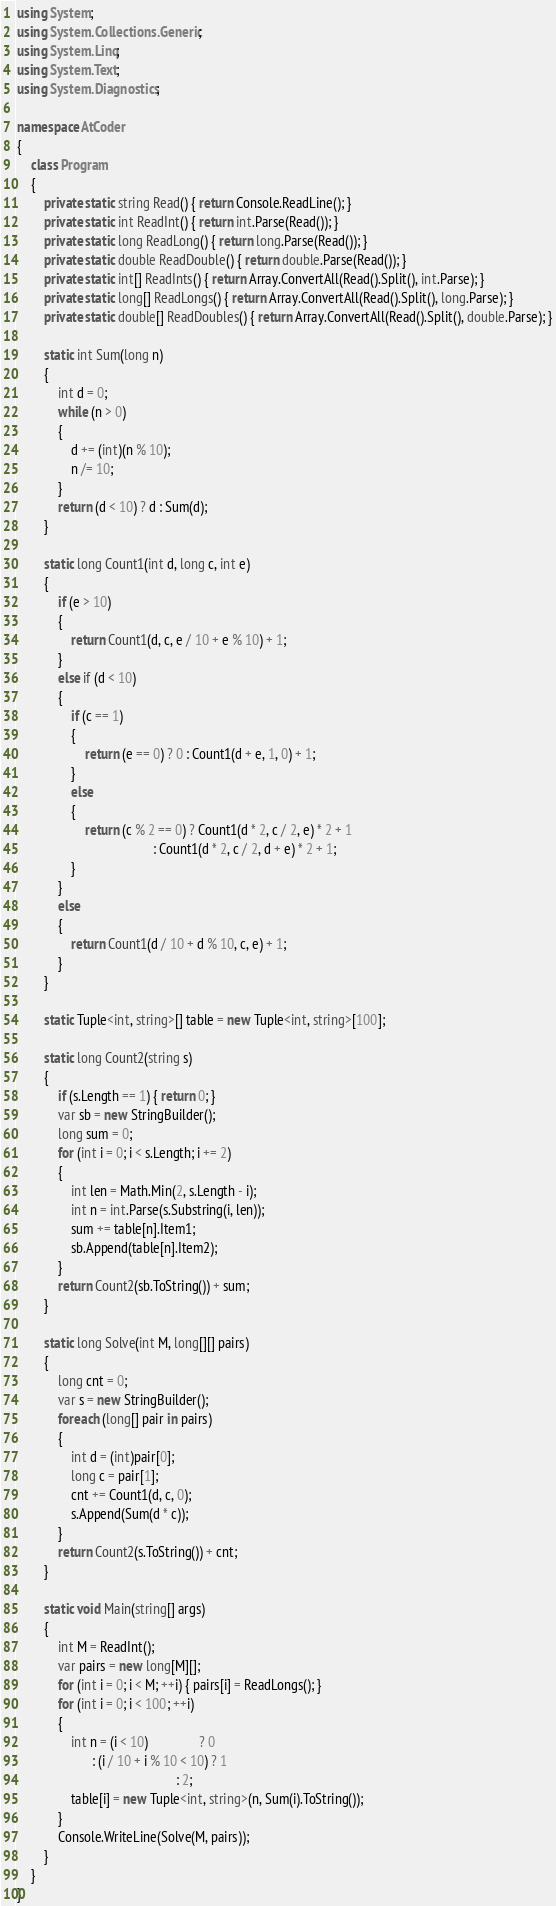Convert code to text. <code><loc_0><loc_0><loc_500><loc_500><_C#_>using System;
using System.Collections.Generic;
using System.Linq;
using System.Text;
using System.Diagnostics;

namespace AtCoder
{
    class Program
    {
        private static string Read() { return Console.ReadLine(); }
        private static int ReadInt() { return int.Parse(Read()); }
        private static long ReadLong() { return long.Parse(Read()); }
        private static double ReadDouble() { return double.Parse(Read()); }
        private static int[] ReadInts() { return Array.ConvertAll(Read().Split(), int.Parse); }
        private static long[] ReadLongs() { return Array.ConvertAll(Read().Split(), long.Parse); }
        private static double[] ReadDoubles() { return Array.ConvertAll(Read().Split(), double.Parse); }

        static int Sum(long n)
        {
            int d = 0;
            while (n > 0)
            {
                d += (int)(n % 10);
                n /= 10;
            }
            return (d < 10) ? d : Sum(d);
        }

        static long Count1(int d, long c, int e)
        {
            if (e > 10)
            {
                return Count1(d, c, e / 10 + e % 10) + 1;
            }
            else if (d < 10)
            {
                if (c == 1)
                {
                    return (e == 0) ? 0 : Count1(d + e, 1, 0) + 1;
                }
                else
                {
                    return (c % 2 == 0) ? Count1(d * 2, c / 2, e) * 2 + 1
                                        : Count1(d * 2, c / 2, d + e) * 2 + 1;
                }
            }
            else
            {
                return Count1(d / 10 + d % 10, c, e) + 1;
            }
        }

        static Tuple<int, string>[] table = new Tuple<int, string>[100];

        static long Count2(string s)
        {
            if (s.Length == 1) { return 0; }
            var sb = new StringBuilder();
            long sum = 0;
            for (int i = 0; i < s.Length; i += 2)
            {
                int len = Math.Min(2, s.Length - i);
                int n = int.Parse(s.Substring(i, len));
                sum += table[n].Item1;
                sb.Append(table[n].Item2);
            }
            return Count2(sb.ToString()) + sum;
        }

        static long Solve(int M, long[][] pairs)
        {
            long cnt = 0;
            var s = new StringBuilder();
            foreach (long[] pair in pairs)
            {
                int d = (int)pair[0];
                long c = pair[1];
                cnt += Count1(d, c, 0);
                s.Append(Sum(d * c));
            }
            return Count2(s.ToString()) + cnt;
        }

        static void Main(string[] args)
        {
            int M = ReadInt();
            var pairs = new long[M][];
            for (int i = 0; i < M; ++i) { pairs[i] = ReadLongs(); }
            for (int i = 0; i < 100; ++i)
            {
                int n = (i < 10)               ? 0
                      : (i / 10 + i % 10 < 10) ? 1
                                               : 2;
                table[i] = new Tuple<int, string>(n, Sum(i).ToString());
            }
            Console.WriteLine(Solve(M, pairs));
        }
    }
}
</code> 